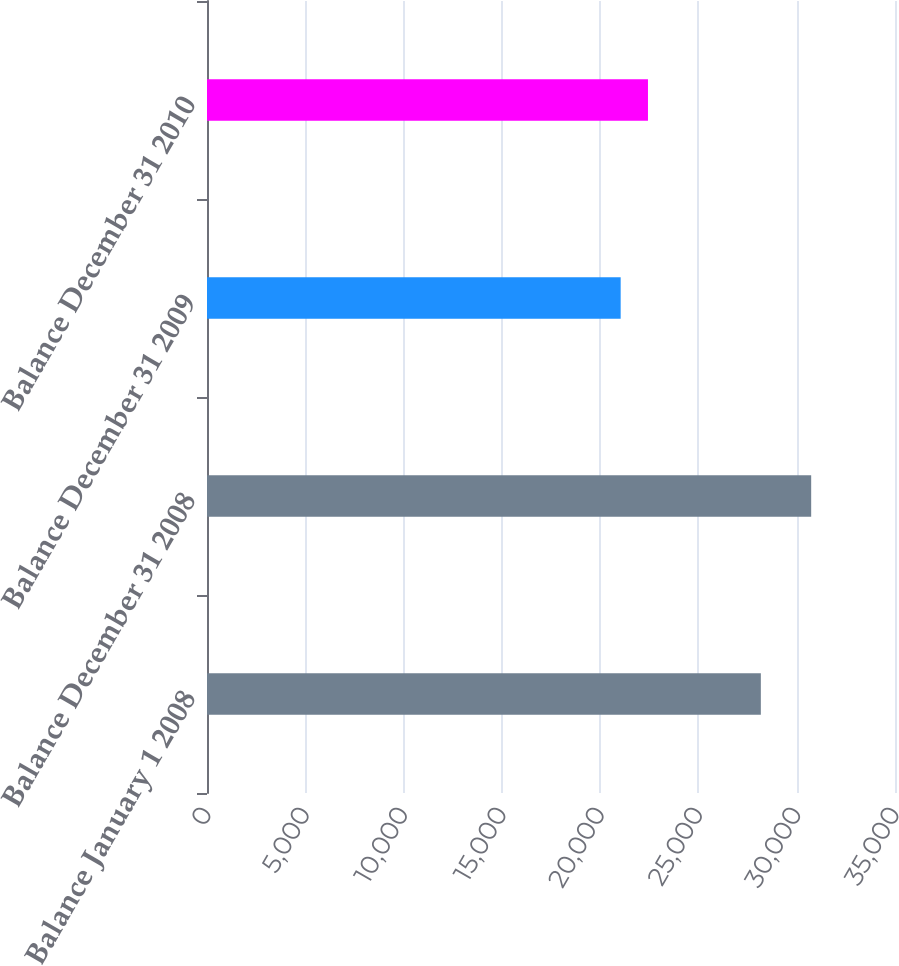Convert chart to OTSL. <chart><loc_0><loc_0><loc_500><loc_500><bar_chart><fcel>Balance January 1 2008<fcel>Balance December 31 2008<fcel>Balance December 31 2009<fcel>Balance December 31 2010<nl><fcel>28175<fcel>30736<fcel>21044<fcel>22433<nl></chart> 